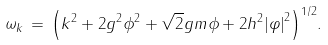Convert formula to latex. <formula><loc_0><loc_0><loc_500><loc_500>\omega _ { k } \, = \, { \left ( k ^ { 2 } + 2 g ^ { 2 } \phi ^ { 2 } + \sqrt { 2 } g m \phi + 2 h ^ { 2 } { | \varphi | } ^ { 2 } \right ) } ^ { 1 / 2 } .</formula> 